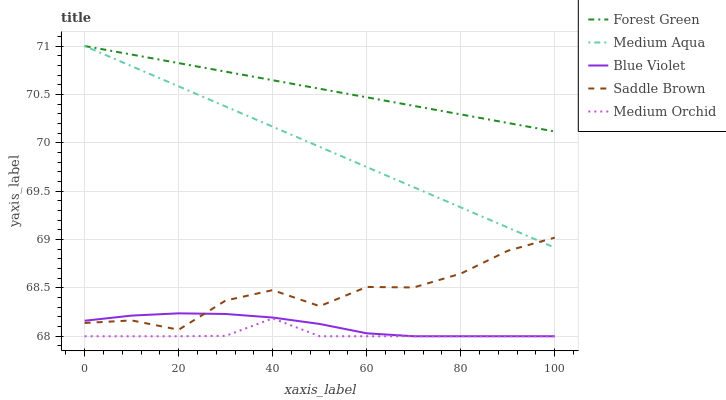Does Medium Orchid have the minimum area under the curve?
Answer yes or no. Yes. Does Forest Green have the maximum area under the curve?
Answer yes or no. Yes. Does Medium Aqua have the minimum area under the curve?
Answer yes or no. No. Does Medium Aqua have the maximum area under the curve?
Answer yes or no. No. Is Medium Aqua the smoothest?
Answer yes or no. Yes. Is Saddle Brown the roughest?
Answer yes or no. Yes. Is Medium Orchid the smoothest?
Answer yes or no. No. Is Medium Orchid the roughest?
Answer yes or no. No. Does Medium Orchid have the lowest value?
Answer yes or no. Yes. Does Medium Aqua have the lowest value?
Answer yes or no. No. Does Medium Aqua have the highest value?
Answer yes or no. Yes. Does Medium Orchid have the highest value?
Answer yes or no. No. Is Medium Orchid less than Medium Aqua?
Answer yes or no. Yes. Is Forest Green greater than Medium Orchid?
Answer yes or no. Yes. Does Blue Violet intersect Medium Orchid?
Answer yes or no. Yes. Is Blue Violet less than Medium Orchid?
Answer yes or no. No. Is Blue Violet greater than Medium Orchid?
Answer yes or no. No. Does Medium Orchid intersect Medium Aqua?
Answer yes or no. No. 